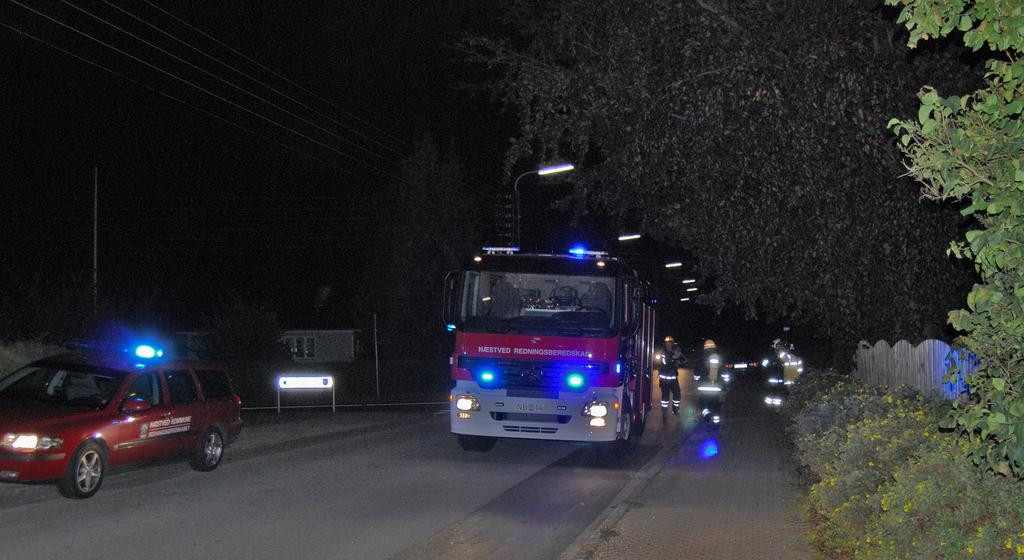What can be seen on the road in the image? There are vehicles on the road in the image. Can you describe the people in the image? There are people in the image. What type of illumination is visible in the image? There are lights visible in the image. What structures can be seen in the image? There are poles in the image. What else is present in the image besides the poles? There are wires in the image. What is the board in the image used for? The purpose of the board in the image is not specified, but it is present. What type of vegetation is visible in the image? There are plants, flowers, and trees in the image. How would you describe the overall appearance of the image? The background of the image is dark. What type of skin condition can be seen on the people in the image? There is no indication of any skin condition on the people in the image. Where is the hospital located in the image? There is no hospital present in the image. 